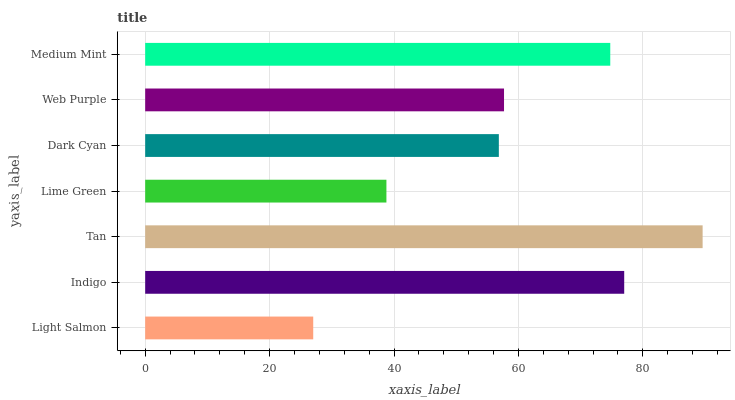Is Light Salmon the minimum?
Answer yes or no. Yes. Is Tan the maximum?
Answer yes or no. Yes. Is Indigo the minimum?
Answer yes or no. No. Is Indigo the maximum?
Answer yes or no. No. Is Indigo greater than Light Salmon?
Answer yes or no. Yes. Is Light Salmon less than Indigo?
Answer yes or no. Yes. Is Light Salmon greater than Indigo?
Answer yes or no. No. Is Indigo less than Light Salmon?
Answer yes or no. No. Is Web Purple the high median?
Answer yes or no. Yes. Is Web Purple the low median?
Answer yes or no. Yes. Is Lime Green the high median?
Answer yes or no. No. Is Dark Cyan the low median?
Answer yes or no. No. 